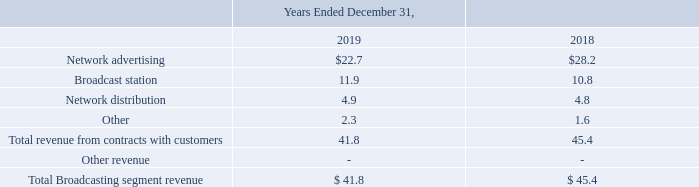Network advertising revenue is generated primarily from the sale of television airtime for programs or advertisements. Network advertising revenue is recognized when the program or advertisement is broadcast. Revenues are reported net of agency commissions, which are calculated as a stated percentage applied to gross billings. The Network advertising contracts are generally short-term in nature.
Network distribution revenue consists of payments received from cable, satellite and other multiple video program distribution systems for their retransmission of our network content. Network distribution revenue is recognized as earned over the life of the retransmission consent contract and varies from month to month.
Variable fees are usage/sales based, calculated on the average number of subscribers, and recognized as revenue when the usage occurs. Transaction prices are based on the contract terms, with no material judgments or estimates.
Broadcast station revenue is generated primarily from the sale of television airtime in return for a fixed fee or a portion of the related ad sales recognized by the third party. In a typical broadcast station revenue agreement, the licensee of a station makes available, for a fee, airtime on its station to a party which supplies content to be broadcast during that airtime and collects revenue from advertising aired during such content.
Broadcast station revenue is recognized over the life of the contract, when the program is broadcast. The fees that we charge can be fixed or variable and the contracts that the Company enters into are generally short-term in nature. Variable fees are usage/salesbased and recognized as revenue when the subsequent usage occurs. Transaction prices are based on the contract terms, with no material judgments or estimates.
Disaggregation of Revenues The following table disaggregates the Broadcasting segment's revenue by type (in millions):
Where is the network advertising revenue generated from? Network advertising revenue is generated primarily from the sale of television airtime for programs or advertisements. What does the network distribution revenue consist of? Network distribution revenue consists of payments received from cable, satellite and other multiple video program distribution systems for their retransmission of our network content. Where is the broadcast revenue generated from? Broadcast station revenue is generated primarily from the sale of television airtime in return for a fixed fee or a portion of the related ad sales recognized by the third party. What is the increase / (decrease) in the network advertising from 2018 to 2019?
Answer scale should be: million. 22.7 - 28.2
Answer: -5.5. What is the average broadcast station?
Answer scale should be: million. (11.9 + 10.8) / 2
Answer: 11.35. What is the percentage increase / (decrease) in the network distribution from 2018 to 2019?
Answer scale should be: percent. 4.9 / 4.8 - 1
Answer: 2.08. 